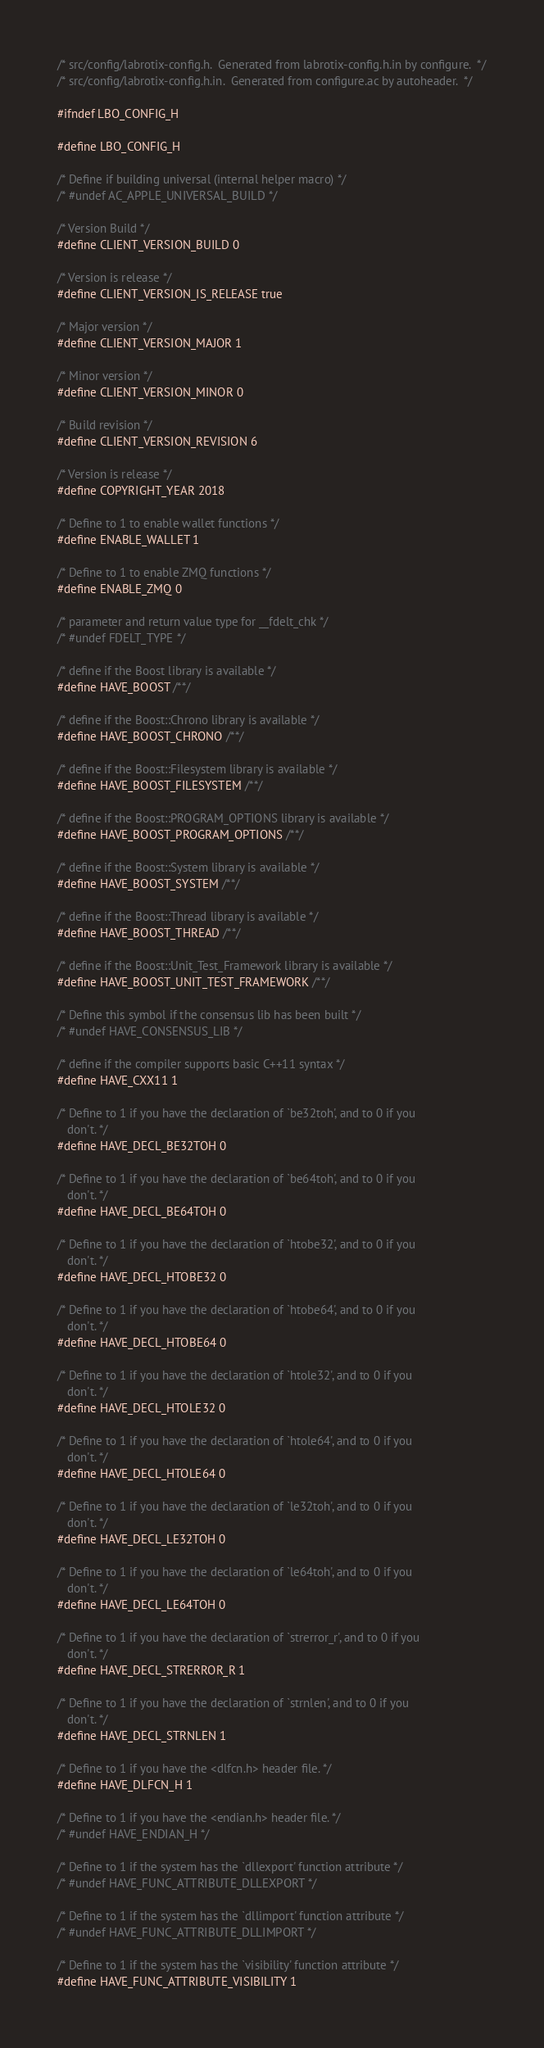Convert code to text. <code><loc_0><loc_0><loc_500><loc_500><_C_>/* src/config/labrotix-config.h.  Generated from labrotix-config.h.in by configure.  */
/* src/config/labrotix-config.h.in.  Generated from configure.ac by autoheader.  */

#ifndef LBO_CONFIG_H

#define LBO_CONFIG_H

/* Define if building universal (internal helper macro) */
/* #undef AC_APPLE_UNIVERSAL_BUILD */

/* Version Build */
#define CLIENT_VERSION_BUILD 0

/* Version is release */
#define CLIENT_VERSION_IS_RELEASE true

/* Major version */
#define CLIENT_VERSION_MAJOR 1

/* Minor version */
#define CLIENT_VERSION_MINOR 0

/* Build revision */
#define CLIENT_VERSION_REVISION 6

/* Version is release */
#define COPYRIGHT_YEAR 2018

/* Define to 1 to enable wallet functions */
#define ENABLE_WALLET 1

/* Define to 1 to enable ZMQ functions */
#define ENABLE_ZMQ 0

/* parameter and return value type for __fdelt_chk */
/* #undef FDELT_TYPE */

/* define if the Boost library is available */
#define HAVE_BOOST /**/

/* define if the Boost::Chrono library is available */
#define HAVE_BOOST_CHRONO /**/

/* define if the Boost::Filesystem library is available */
#define HAVE_BOOST_FILESYSTEM /**/

/* define if the Boost::PROGRAM_OPTIONS library is available */
#define HAVE_BOOST_PROGRAM_OPTIONS /**/

/* define if the Boost::System library is available */
#define HAVE_BOOST_SYSTEM /**/

/* define if the Boost::Thread library is available */
#define HAVE_BOOST_THREAD /**/

/* define if the Boost::Unit_Test_Framework library is available */
#define HAVE_BOOST_UNIT_TEST_FRAMEWORK /**/

/* Define this symbol if the consensus lib has been built */
/* #undef HAVE_CONSENSUS_LIB */

/* define if the compiler supports basic C++11 syntax */
#define HAVE_CXX11 1

/* Define to 1 if you have the declaration of `be32toh', and to 0 if you
   don't. */
#define HAVE_DECL_BE32TOH 0

/* Define to 1 if you have the declaration of `be64toh', and to 0 if you
   don't. */
#define HAVE_DECL_BE64TOH 0

/* Define to 1 if you have the declaration of `htobe32', and to 0 if you
   don't. */
#define HAVE_DECL_HTOBE32 0

/* Define to 1 if you have the declaration of `htobe64', and to 0 if you
   don't. */
#define HAVE_DECL_HTOBE64 0

/* Define to 1 if you have the declaration of `htole32', and to 0 if you
   don't. */
#define HAVE_DECL_HTOLE32 0

/* Define to 1 if you have the declaration of `htole64', and to 0 if you
   don't. */
#define HAVE_DECL_HTOLE64 0

/* Define to 1 if you have the declaration of `le32toh', and to 0 if you
   don't. */
#define HAVE_DECL_LE32TOH 0

/* Define to 1 if you have the declaration of `le64toh', and to 0 if you
   don't. */
#define HAVE_DECL_LE64TOH 0

/* Define to 1 if you have the declaration of `strerror_r', and to 0 if you
   don't. */
#define HAVE_DECL_STRERROR_R 1

/* Define to 1 if you have the declaration of `strnlen', and to 0 if you
   don't. */
#define HAVE_DECL_STRNLEN 1

/* Define to 1 if you have the <dlfcn.h> header file. */
#define HAVE_DLFCN_H 1

/* Define to 1 if you have the <endian.h> header file. */
/* #undef HAVE_ENDIAN_H */

/* Define to 1 if the system has the `dllexport' function attribute */
/* #undef HAVE_FUNC_ATTRIBUTE_DLLEXPORT */

/* Define to 1 if the system has the `dllimport' function attribute */
/* #undef HAVE_FUNC_ATTRIBUTE_DLLIMPORT */

/* Define to 1 if the system has the `visibility' function attribute */
#define HAVE_FUNC_ATTRIBUTE_VISIBILITY 1
</code> 